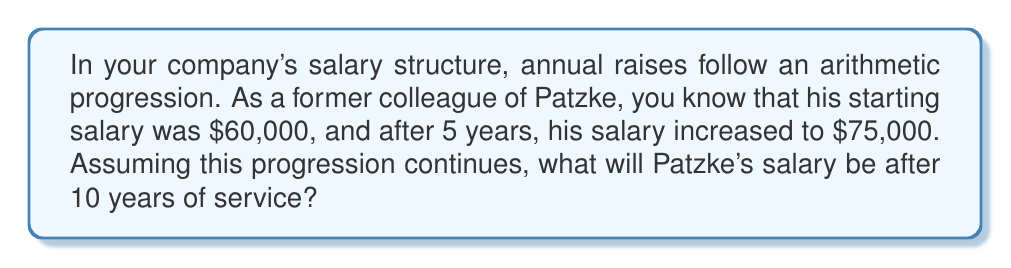Solve this math problem. Let's approach this step-by-step:

1) In an arithmetic progression, the difference between each term is constant. Let's call this common difference $d$.

2) We know:
   - Initial salary (a₁) = $60,000
   - Salary after 5 years (a₅) = $75,000

3) The formula for the nth term of an arithmetic progression is:
   $a_n = a_1 + (n-1)d$

4) We can use this to find $d$:
   $75,000 = 60,000 + (5-1)d$
   $75,000 = 60,000 + 4d$
   $15,000 = 4d$
   $d = 3,750$

5) So, the salary increases by $3,750 each year.

6) To find the salary after 10 years, we use the same formula with $n = 10$:
   $a_{10} = 60,000 + (10-1)3,750$
   $a_{10} = 60,000 + 9(3,750)$
   $a_{10} = 60,000 + 33,750$
   $a_{10} = 93,750$

Therefore, after 10 years, Patzke's salary will be $93,750.
Answer: $93,750 